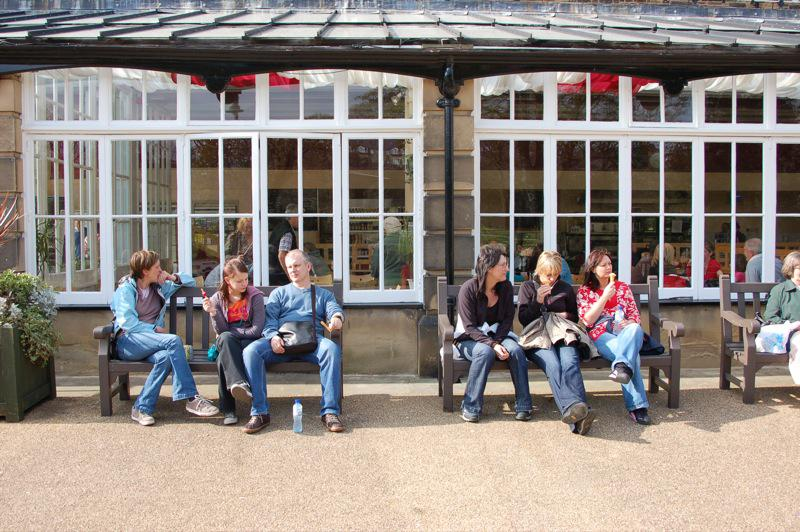Question: where are the windows located?
Choices:
A. In the church.
B. Behind the people sitting on benches.
C. In the entryway.
D. In the back room.
Answer with the letter. Answer: B Question: who has a water bottle between their legs?
Choices:
A. Man sitting on the far left bench.
B. Woman sitting on edge of bench.
C. Child sitting in the middle.
D. Older man sitting on the ground.
Answer with the letter. Answer: A Question: why are there shadows in the image?
Choices:
A. Because the camera is cheap.
B. Because it is sunny outside.
C. Because the lens is dirty.
D. Because the lighting is wrong.
Answer with the letter. Answer: B Question: what is to the left of the far left bench?
Choices:
A. A sculpture.
B. A fountain.
C. A plant.
D. A person.
Answer with the letter. Answer: C Question: where is the plant?
Choices:
A. On the left.
B. Next to the soil.
C. In the dirt.
D. On the table.
Answer with the letter. Answer: A Question: who has a black messenger bag?
Choices:
A. The boy on the bike.
B. One man.
C. The girl in the uniform.
D. The woman wearing the hat.
Answer with the letter. Answer: B Question: when are they there?
Choices:
A. During daytime.
B. During lunch.
C. After work.
D. At night.
Answer with the letter. Answer: A Question: what are the benches made of?
Choices:
A. Metal.
B. Concrete.
C. Plastic.
D. Wood.
Answer with the letter. Answer: D Question: who is eating on a bench?
Choices:
A. The girl in the sundress.
B. The boy in the black baseball hat.
C. The man in the plaid shirt.
D. A woman with shoulder-length hair and a red and white top.
Answer with the letter. Answer: D Question: who are outside?
Choices:
A. The dogs.
B. The people.
C. The children.
D. The cats.
Answer with the letter. Answer: B Question: what is on the exterior portion of a building?
Choices:
A. A black, decorative overhang and posts.
B. A mural.
C. An awning.
D. A poster.
Answer with the letter. Answer: A Question: who has a jacket on her lap?
Choices:
A. The woman on the right bench and is looking down.
B. The girl with the backpack.
C. The woman reading the newspaper.
D. The child in the stroller.
Answer with the letter. Answer: A Question: who is eating icecream?
Choices:
A. The man.
B. The boy.
C. The woman.
D. The girl.
Answer with the letter. Answer: C Question: how many people have jeans on?
Choices:
A. Three.
B. Two.
C. One.
D. Five people have jeans on.
Answer with the letter. Answer: D Question: how does the weather look?
Choices:
A. It is cloudy.
B. It is raining.
C. It is snowing.
D. It seems to be sunny.
Answer with the letter. Answer: D Question: what is on the left?
Choices:
A. A plant.
B. A car.
C. A person.
D. A building.
Answer with the letter. Answer: A 